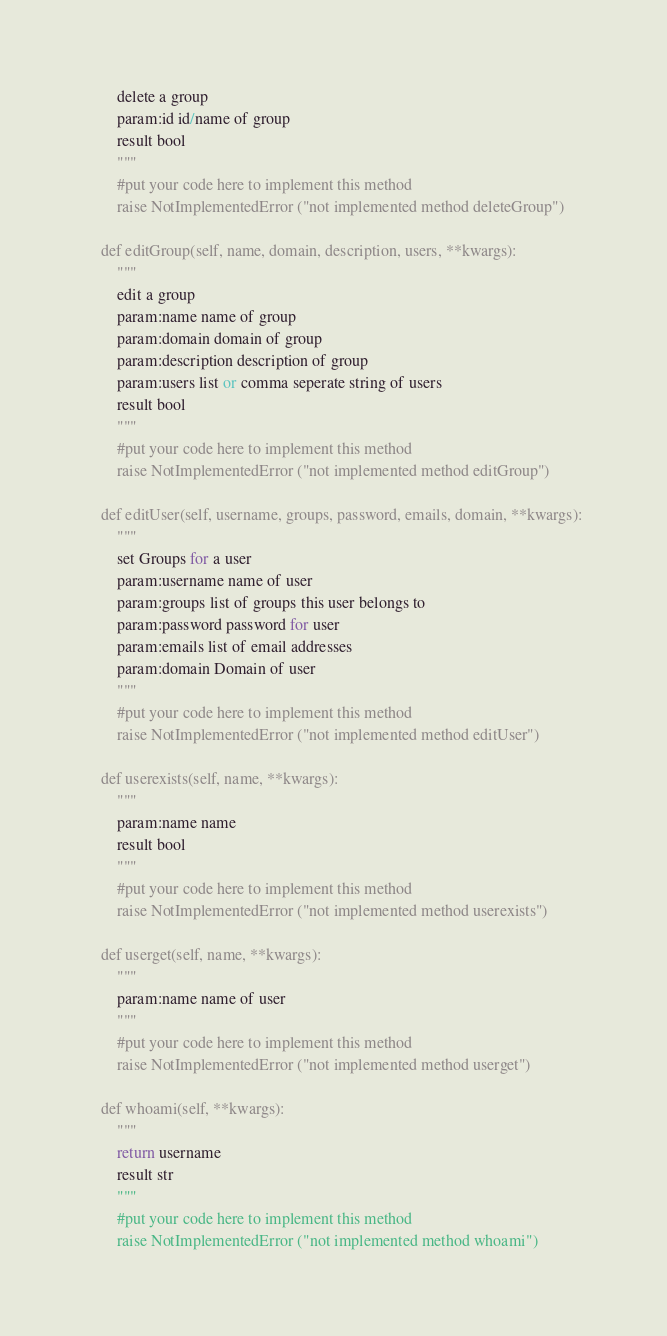Convert code to text. <code><loc_0><loc_0><loc_500><loc_500><_Python_>        delete a group
        param:id id/name of group
        result bool
        """
        #put your code here to implement this method
        raise NotImplementedError ("not implemented method deleteGroup")

    def editGroup(self, name, domain, description, users, **kwargs):
        """
        edit a group
        param:name name of group
        param:domain domain of group
        param:description description of group
        param:users list or comma seperate string of users
        result bool
        """
        #put your code here to implement this method
        raise NotImplementedError ("not implemented method editGroup")

    def editUser(self, username, groups, password, emails, domain, **kwargs):
        """
        set Groups for a user
        param:username name of user
        param:groups list of groups this user belongs to
        param:password password for user
        param:emails list of email addresses
        param:domain Domain of user
        """
        #put your code here to implement this method
        raise NotImplementedError ("not implemented method editUser")

    def userexists(self, name, **kwargs):
        """
        param:name name
        result bool
        """
        #put your code here to implement this method
        raise NotImplementedError ("not implemented method userexists")

    def userget(self, name, **kwargs):
        """
        param:name name of user
        """
        #put your code here to implement this method
        raise NotImplementedError ("not implemented method userget")

    def whoami(self, **kwargs):
        """
        return username
        result str
        """
        #put your code here to implement this method
        raise NotImplementedError ("not implemented method whoami")
</code> 